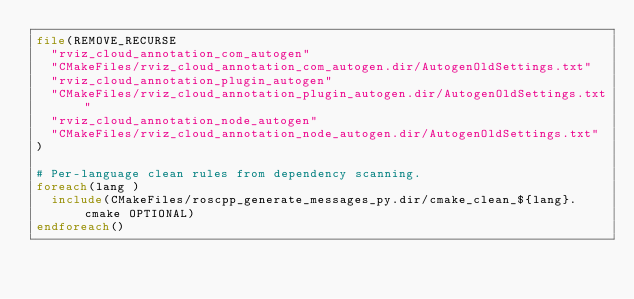<code> <loc_0><loc_0><loc_500><loc_500><_CMake_>file(REMOVE_RECURSE
  "rviz_cloud_annotation_com_autogen"
  "CMakeFiles/rviz_cloud_annotation_com_autogen.dir/AutogenOldSettings.txt"
  "rviz_cloud_annotation_plugin_autogen"
  "CMakeFiles/rviz_cloud_annotation_plugin_autogen.dir/AutogenOldSettings.txt"
  "rviz_cloud_annotation_node_autogen"
  "CMakeFiles/rviz_cloud_annotation_node_autogen.dir/AutogenOldSettings.txt"
)

# Per-language clean rules from dependency scanning.
foreach(lang )
  include(CMakeFiles/roscpp_generate_messages_py.dir/cmake_clean_${lang}.cmake OPTIONAL)
endforeach()
</code> 